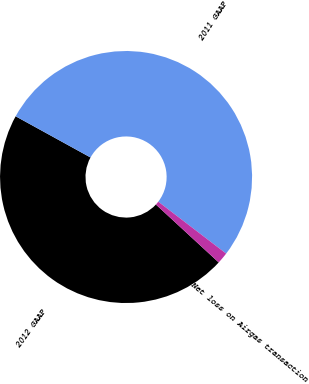Convert chart to OTSL. <chart><loc_0><loc_0><loc_500><loc_500><pie_chart><fcel>2012 GAAP<fcel>2011 GAAP<fcel>Net loss on Airgas transaction<nl><fcel>46.15%<fcel>52.39%<fcel>1.46%<nl></chart> 